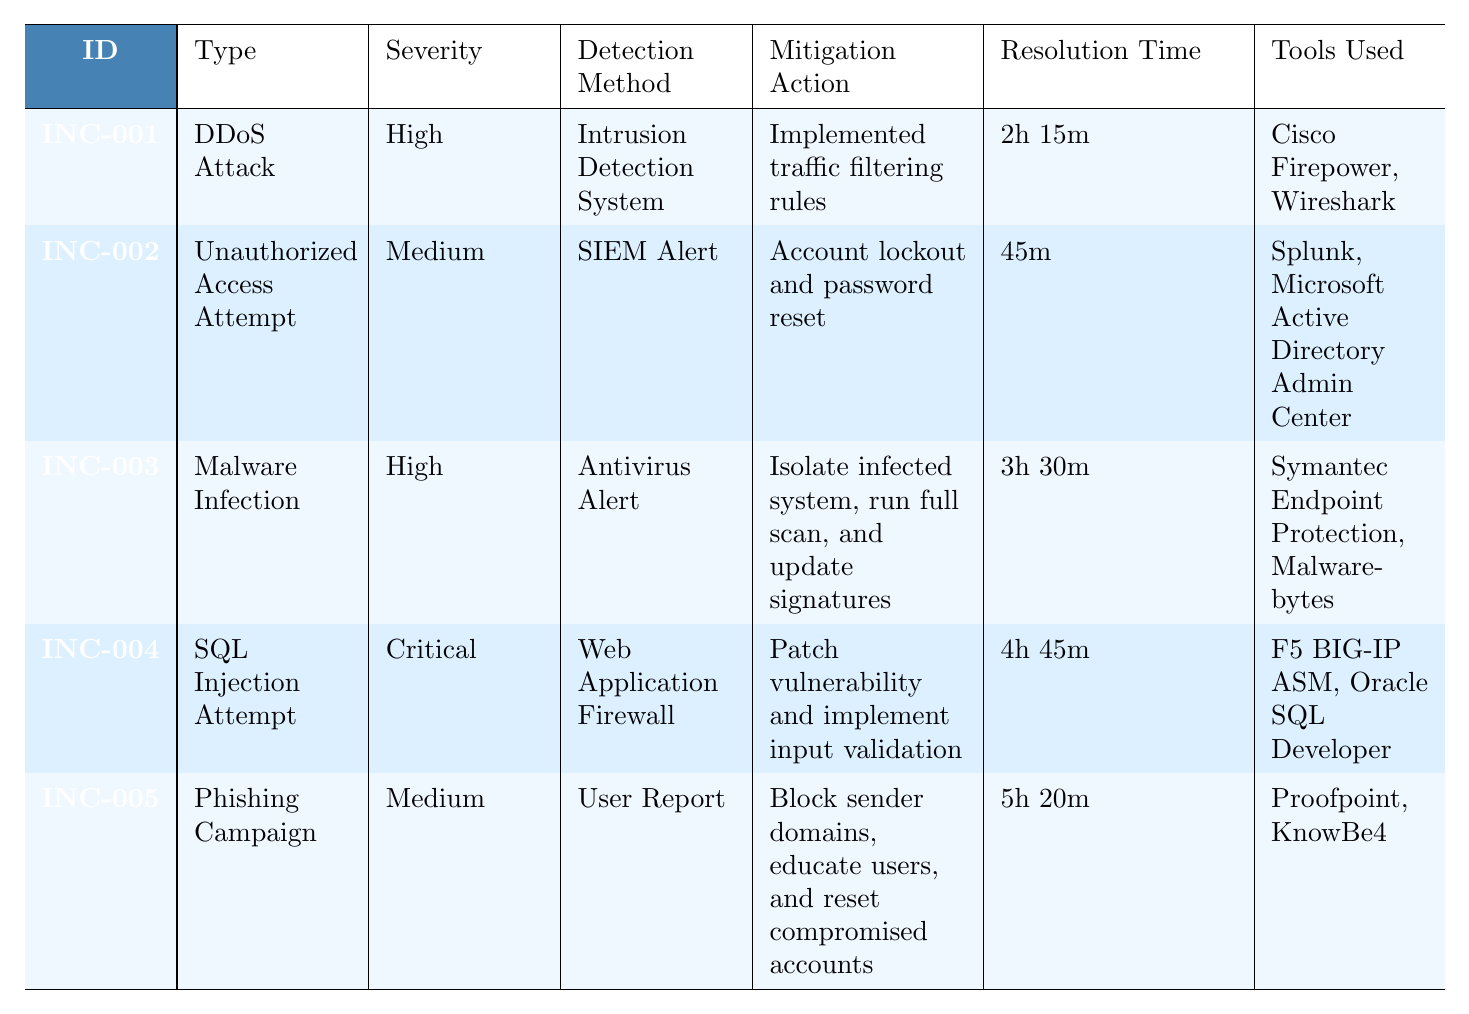What is the type of incident with ID INC-003? By locating the row with ID INC-003 in the table, I can see that the "Type" column is filled with "Malware Infection".
Answer: Malware Infection Which incident had the longest resolution time? Reviewing the "Resolution Time" column, the longest time is 5 hours 20 minutes for the incident with ID INC-005.
Answer: INC-005 How many unique types of incidents are listed in the table? The types of incidents include DDoS Attack, Unauthorized Access Attempt, Malware Infection, SQL Injection Attempt, and Phishing Campaign. Counting these provides a total of 5 unique types.
Answer: 5 Was the detection method for the SQL Injection Attempt the same as that for the Unauthorized Access Attempt? The detection method for SQL Injection Attempt (INC-004) is "Web Application Firewall" and for Unauthorized Access Attempt (INC-002) is "SIEM Alert". Since these are different, the answer is no.
Answer: No What is the total resolution time for the incidents categorized as High severity? The resolution times for High severity incidents (INC-001 and INC-003) are 2 hours 15 minutes (135 minutes) and 3 hours 30 minutes (210 minutes). Adding these gives 135 + 210 = 345 minutes which equals 5 hours 45 minutes.
Answer: 5 hours 45 minutes Which team was involved in handling the malware infection incident? The teams involved in the incident with ID INC-003 (Malware Infection) are listed in the "Team Involved" column, which includes IT Support, Security, and Marketing.
Answer: IT Support, Security, Marketing Is there any incident that involved a User Report as a detection method? Looking at the "Detection Method" column, I can see that "User Report" is specifically noted for the Phishing Campaign incident (INC-005). Therefore, the answer is yes.
Answer: Yes For which incident type was the impact on email services noted? Upon examining the "Impacted Services" column for each incident, the Phishing Campaign (INC-005) is the only one which notes an impact on email services.
Answer: Phishing Campaign What kind of tools were used to mitigate the SQL Injection Attempt? In the row for the SQL Injection Attempt incident (INC-004), the "Tools Used" column lists “F5 BIG-IP ASM” and “Oracle SQL Developer” as the tools used for mitigation.
Answer: F5 BIG-IP ASM, Oracle SQL Developer Which incident had a Critical severity level? The incident with ID INC-004 is labeled as having a Critical severity level, as seen in the "Severity" column.
Answer: INC-004 How many teams were involved in the DDoS Attack incident? For the DDoS Attack incident (INC-001), the "Team Involved" column indicates that two teams were involved: Network Operations and Security.
Answer: 2 